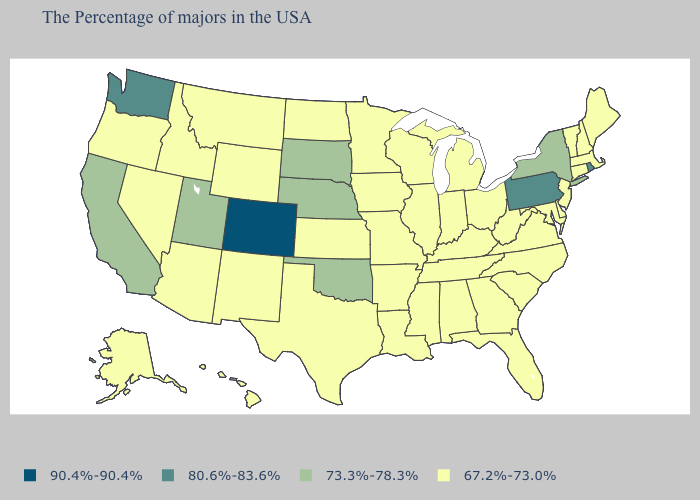What is the value of Mississippi?
Give a very brief answer. 67.2%-73.0%. Among the states that border Oregon , which have the highest value?
Keep it brief. Washington. Which states have the lowest value in the South?
Concise answer only. Delaware, Maryland, Virginia, North Carolina, South Carolina, West Virginia, Florida, Georgia, Kentucky, Alabama, Tennessee, Mississippi, Louisiana, Arkansas, Texas. Is the legend a continuous bar?
Quick response, please. No. Name the states that have a value in the range 73.3%-78.3%?
Concise answer only. New York, Nebraska, Oklahoma, South Dakota, Utah, California. What is the value of Wisconsin?
Write a very short answer. 67.2%-73.0%. Does North Dakota have a higher value than Illinois?
Be succinct. No. Does South Dakota have the highest value in the MidWest?
Write a very short answer. Yes. Does Illinois have the lowest value in the USA?
Answer briefly. Yes. Does Utah have the lowest value in the West?
Quick response, please. No. What is the highest value in states that border Texas?
Quick response, please. 73.3%-78.3%. Name the states that have a value in the range 90.4%-90.4%?
Concise answer only. Colorado. How many symbols are there in the legend?
Concise answer only. 4. Does Colorado have the highest value in the West?
Be succinct. Yes. Does Nebraska have a lower value than Pennsylvania?
Keep it brief. Yes. 